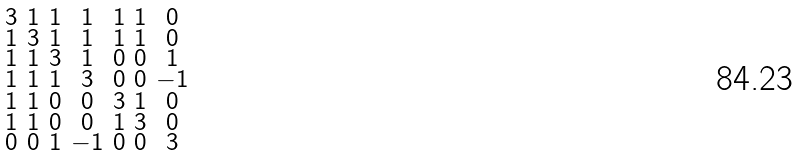Convert formula to latex. <formula><loc_0><loc_0><loc_500><loc_500>\begin{smallmatrix} 3 & 1 & 1 & 1 & 1 & 1 & 0 \\ 1 & 3 & 1 & 1 & 1 & 1 & 0 \\ 1 & 1 & 3 & 1 & 0 & 0 & 1 \\ 1 & 1 & 1 & 3 & 0 & 0 & - 1 \\ 1 & 1 & 0 & 0 & 3 & 1 & 0 \\ 1 & 1 & 0 & 0 & 1 & 3 & 0 \\ 0 & 0 & 1 & - 1 & 0 & 0 & 3 \end{smallmatrix}</formula> 